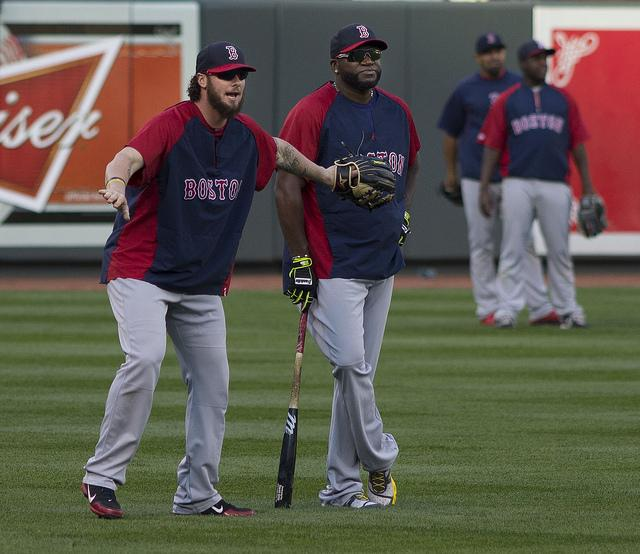What team do the men on the field play for? boston 